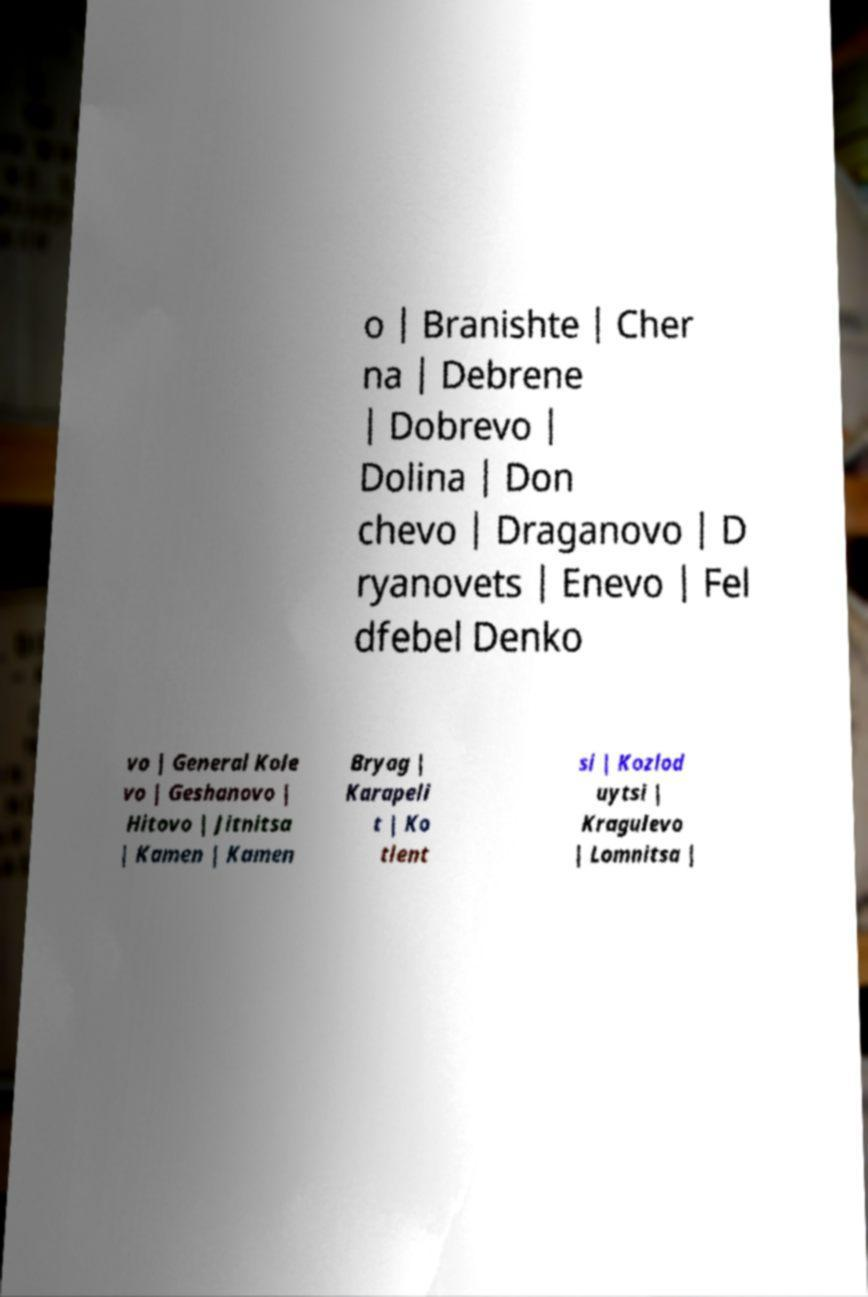Can you accurately transcribe the text from the provided image for me? o | Branishte | Cher na | Debrene | Dobrevo | Dolina | Don chevo | Draganovo | D ryanovets | Enevo | Fel dfebel Denko vo | General Kole vo | Geshanovo | Hitovo | Jitnitsa | Kamen | Kamen Bryag | Karapeli t | Ko tlent si | Kozlod uytsi | Kragulevo | Lomnitsa | 